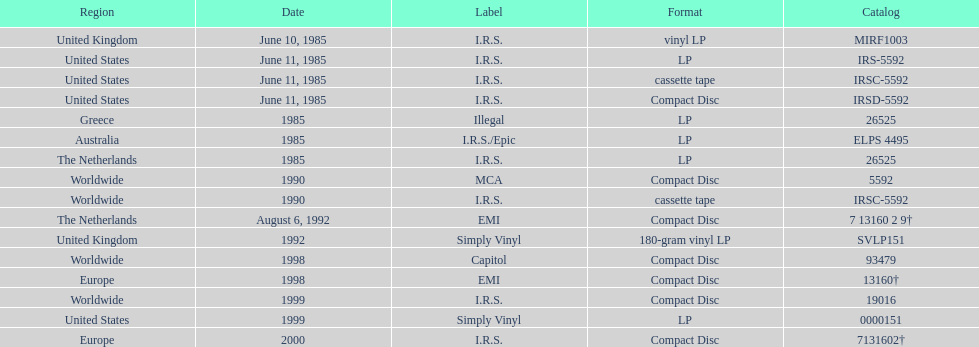Help me parse the entirety of this table. {'header': ['Region', 'Date', 'Label', 'Format', 'Catalog'], 'rows': [['United Kingdom', 'June 10, 1985', 'I.R.S.', 'vinyl LP', 'MIRF1003'], ['United States', 'June 11, 1985', 'I.R.S.', 'LP', 'IRS-5592'], ['United States', 'June 11, 1985', 'I.R.S.', 'cassette tape', 'IRSC-5592'], ['United States', 'June 11, 1985', 'I.R.S.', 'Compact Disc', 'IRSD-5592'], ['Greece', '1985', 'Illegal', 'LP', '26525'], ['Australia', '1985', 'I.R.S./Epic', 'LP', 'ELPS 4495'], ['The Netherlands', '1985', 'I.R.S.', 'LP', '26525'], ['Worldwide', '1990', 'MCA', 'Compact Disc', '5592'], ['Worldwide', '1990', 'I.R.S.', 'cassette tape', 'IRSC-5592'], ['The Netherlands', 'August 6, 1992', 'EMI', 'Compact Disc', '7 13160 2 9†'], ['United Kingdom', '1992', 'Simply Vinyl', '180-gram vinyl LP', 'SVLP151'], ['Worldwide', '1998', 'Capitol', 'Compact Disc', '93479'], ['Europe', '1998', 'EMI', 'Compact Disc', '13160†'], ['Worldwide', '1999', 'I.R.S.', 'Compact Disc', '19016'], ['United States', '1999', 'Simply Vinyl', 'LP', '0000151'], ['Europe', '2000', 'I.R.S.', 'Compact Disc', '7131602†']]} What was the date of the initial vinyl lp launch? June 10, 1985. 